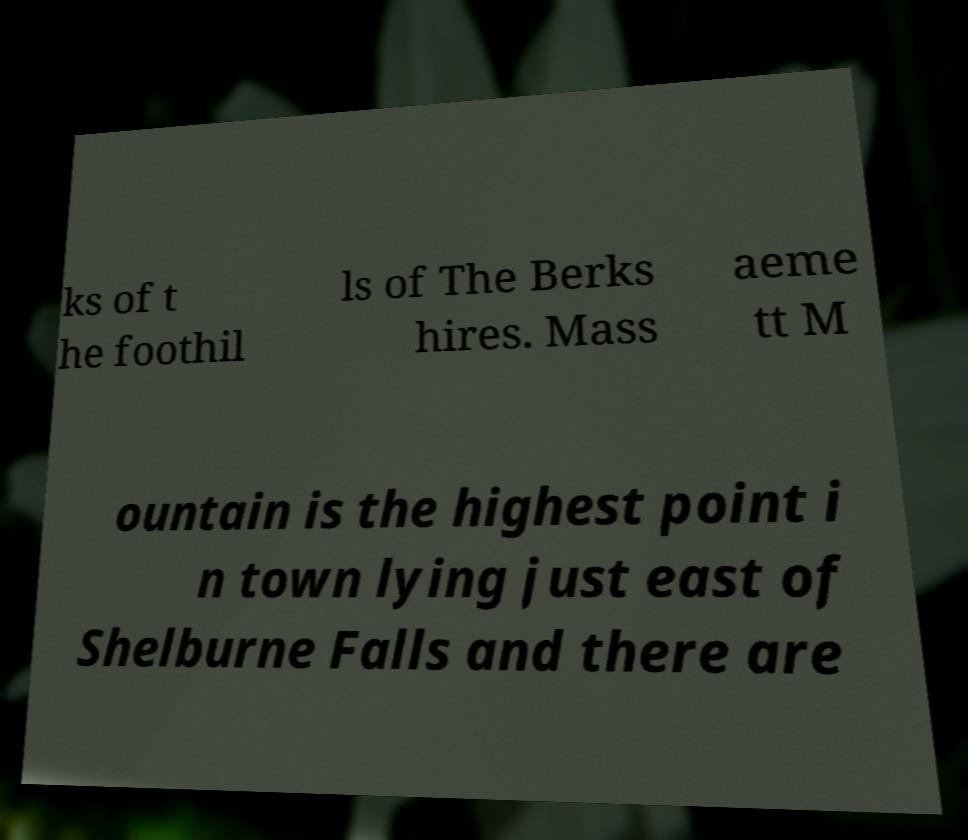Can you accurately transcribe the text from the provided image for me? ks of t he foothil ls of The Berks hires. Mass aeme tt M ountain is the highest point i n town lying just east of Shelburne Falls and there are 